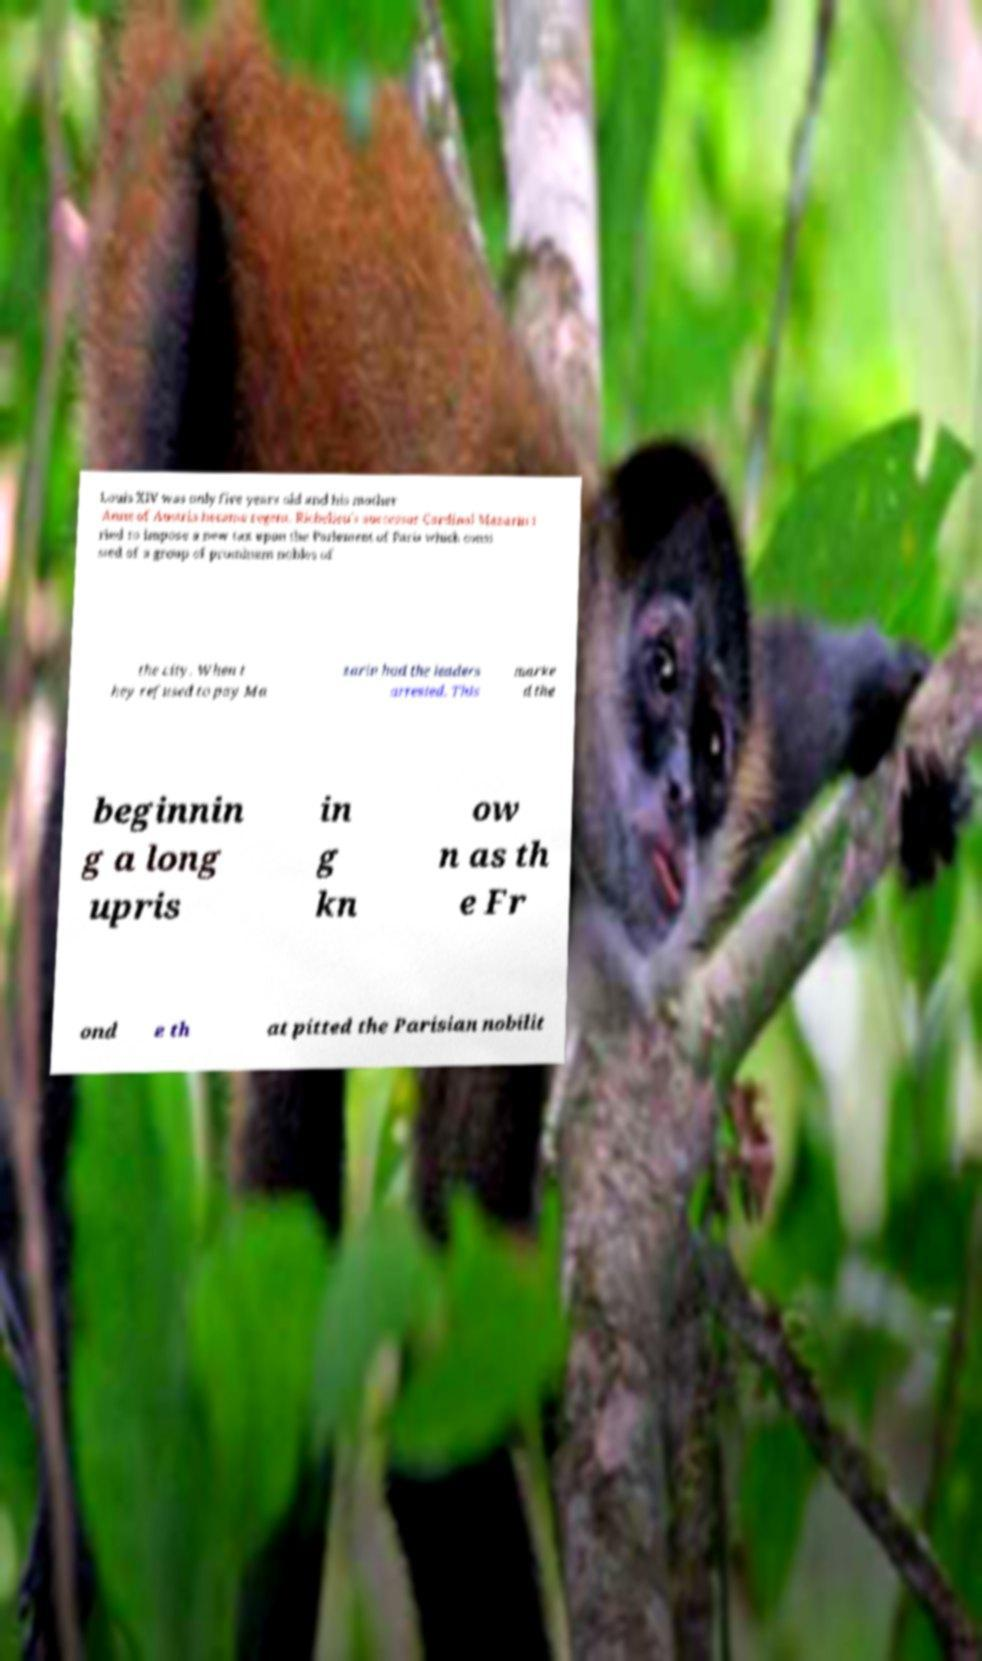Could you extract and type out the text from this image? Louis XIV was only five years old and his mother Anne of Austria became regent. Richelieu's successor Cardinal Mazarin t ried to impose a new tax upon the Parlement of Paris which consi sted of a group of prominent nobles of the city. When t hey refused to pay Ma zarin had the leaders arrested. This marke d the beginnin g a long upris in g kn ow n as th e Fr ond e th at pitted the Parisian nobilit 